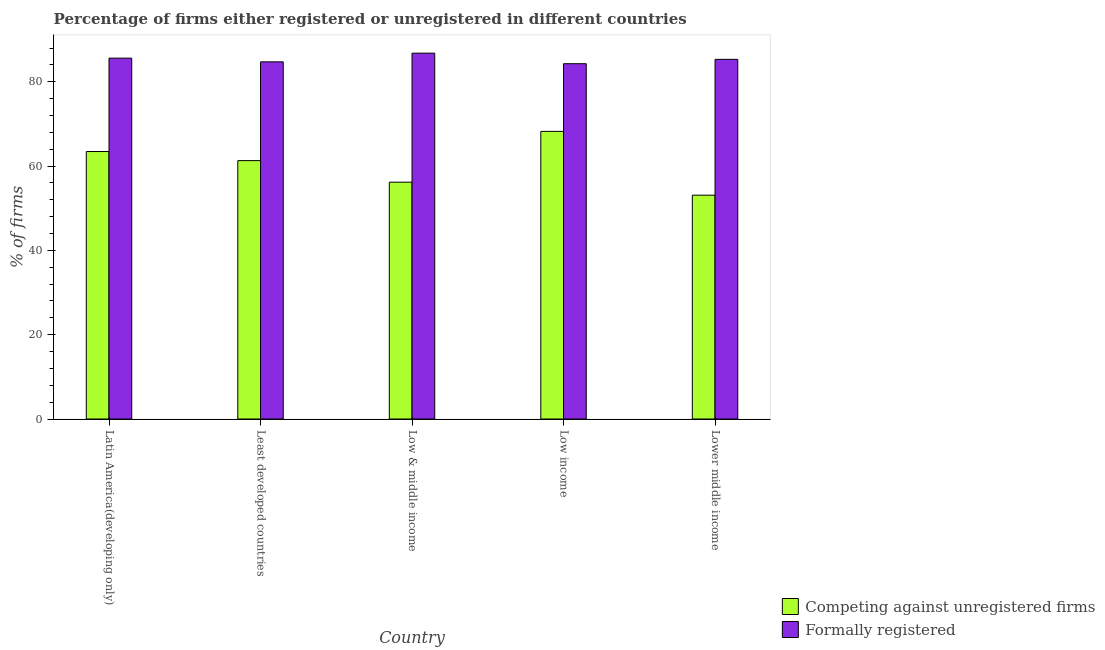Are the number of bars per tick equal to the number of legend labels?
Ensure brevity in your answer.  Yes. How many bars are there on the 5th tick from the left?
Keep it short and to the point. 2. What is the label of the 1st group of bars from the left?
Give a very brief answer. Latin America(developing only). In how many cases, is the number of bars for a given country not equal to the number of legend labels?
Your response must be concise. 0. What is the percentage of registered firms in Low income?
Offer a terse response. 68.23. Across all countries, what is the maximum percentage of formally registered firms?
Keep it short and to the point. 86.79. Across all countries, what is the minimum percentage of registered firms?
Ensure brevity in your answer.  53.1. In which country was the percentage of formally registered firms minimum?
Offer a very short reply. Low income. What is the total percentage of formally registered firms in the graph?
Keep it short and to the point. 426.72. What is the difference between the percentage of formally registered firms in Least developed countries and that in Low income?
Give a very brief answer. 0.44. What is the difference between the percentage of formally registered firms in Lower middle income and the percentage of registered firms in Low & middle income?
Make the answer very short. 29.14. What is the average percentage of registered firms per country?
Keep it short and to the point. 60.45. What is the difference between the percentage of registered firms and percentage of formally registered firms in Low income?
Provide a succinct answer. -16.05. In how many countries, is the percentage of registered firms greater than 76 %?
Keep it short and to the point. 0. What is the ratio of the percentage of registered firms in Latin America(developing only) to that in Lower middle income?
Offer a very short reply. 1.2. What is the difference between the highest and the second highest percentage of registered firms?
Your answer should be compact. 4.78. What is the difference between the highest and the lowest percentage of registered firms?
Your answer should be compact. 15.13. In how many countries, is the percentage of formally registered firms greater than the average percentage of formally registered firms taken over all countries?
Offer a terse response. 2. What does the 1st bar from the left in Latin America(developing only) represents?
Offer a very short reply. Competing against unregistered firms. What does the 2nd bar from the right in Low income represents?
Your answer should be very brief. Competing against unregistered firms. How many bars are there?
Offer a very short reply. 10. How many countries are there in the graph?
Provide a succinct answer. 5. Does the graph contain any zero values?
Your answer should be very brief. No. Does the graph contain grids?
Keep it short and to the point. No. Where does the legend appear in the graph?
Keep it short and to the point. Bottom right. What is the title of the graph?
Your answer should be compact. Percentage of firms either registered or unregistered in different countries. Does "Canada" appear as one of the legend labels in the graph?
Provide a short and direct response. No. What is the label or title of the X-axis?
Offer a very short reply. Country. What is the label or title of the Y-axis?
Keep it short and to the point. % of firms. What is the % of firms of Competing against unregistered firms in Latin America(developing only)?
Keep it short and to the point. 63.45. What is the % of firms of Formally registered in Latin America(developing only)?
Your answer should be compact. 85.6. What is the % of firms in Competing against unregistered firms in Least developed countries?
Your response must be concise. 61.3. What is the % of firms in Formally registered in Least developed countries?
Provide a short and direct response. 84.72. What is the % of firms in Competing against unregistered firms in Low & middle income?
Offer a very short reply. 56.18. What is the % of firms of Formally registered in Low & middle income?
Your answer should be compact. 86.79. What is the % of firms in Competing against unregistered firms in Low income?
Keep it short and to the point. 68.23. What is the % of firms in Formally registered in Low income?
Your response must be concise. 84.28. What is the % of firms of Competing against unregistered firms in Lower middle income?
Give a very brief answer. 53.1. What is the % of firms in Formally registered in Lower middle income?
Offer a terse response. 85.32. Across all countries, what is the maximum % of firms of Competing against unregistered firms?
Ensure brevity in your answer.  68.23. Across all countries, what is the maximum % of firms of Formally registered?
Provide a succinct answer. 86.79. Across all countries, what is the minimum % of firms of Competing against unregistered firms?
Ensure brevity in your answer.  53.1. Across all countries, what is the minimum % of firms of Formally registered?
Give a very brief answer. 84.28. What is the total % of firms of Competing against unregistered firms in the graph?
Keep it short and to the point. 302.26. What is the total % of firms in Formally registered in the graph?
Keep it short and to the point. 426.72. What is the difference between the % of firms in Competing against unregistered firms in Latin America(developing only) and that in Least developed countries?
Your answer should be very brief. 2.16. What is the difference between the % of firms of Formally registered in Latin America(developing only) and that in Least developed countries?
Provide a succinct answer. 0.88. What is the difference between the % of firms in Competing against unregistered firms in Latin America(developing only) and that in Low & middle income?
Provide a short and direct response. 7.28. What is the difference between the % of firms of Formally registered in Latin America(developing only) and that in Low & middle income?
Your answer should be very brief. -1.18. What is the difference between the % of firms of Competing against unregistered firms in Latin America(developing only) and that in Low income?
Provide a succinct answer. -4.78. What is the difference between the % of firms of Formally registered in Latin America(developing only) and that in Low income?
Offer a very short reply. 1.32. What is the difference between the % of firms of Competing against unregistered firms in Latin America(developing only) and that in Lower middle income?
Keep it short and to the point. 10.36. What is the difference between the % of firms of Formally registered in Latin America(developing only) and that in Lower middle income?
Your response must be concise. 0.28. What is the difference between the % of firms of Competing against unregistered firms in Least developed countries and that in Low & middle income?
Provide a short and direct response. 5.12. What is the difference between the % of firms in Formally registered in Least developed countries and that in Low & middle income?
Your answer should be compact. -2.06. What is the difference between the % of firms in Competing against unregistered firms in Least developed countries and that in Low income?
Offer a terse response. -6.93. What is the difference between the % of firms of Formally registered in Least developed countries and that in Low income?
Your answer should be compact. 0.44. What is the difference between the % of firms of Competing against unregistered firms in Least developed countries and that in Lower middle income?
Offer a very short reply. 8.2. What is the difference between the % of firms in Formally registered in Least developed countries and that in Lower middle income?
Your answer should be very brief. -0.59. What is the difference between the % of firms in Competing against unregistered firms in Low & middle income and that in Low income?
Offer a terse response. -12.05. What is the difference between the % of firms in Formally registered in Low & middle income and that in Low income?
Your answer should be compact. 2.5. What is the difference between the % of firms of Competing against unregistered firms in Low & middle income and that in Lower middle income?
Provide a short and direct response. 3.08. What is the difference between the % of firms in Formally registered in Low & middle income and that in Lower middle income?
Offer a terse response. 1.47. What is the difference between the % of firms of Competing against unregistered firms in Low income and that in Lower middle income?
Provide a short and direct response. 15.13. What is the difference between the % of firms in Formally registered in Low income and that in Lower middle income?
Provide a succinct answer. -1.04. What is the difference between the % of firms of Competing against unregistered firms in Latin America(developing only) and the % of firms of Formally registered in Least developed countries?
Provide a short and direct response. -21.27. What is the difference between the % of firms of Competing against unregistered firms in Latin America(developing only) and the % of firms of Formally registered in Low & middle income?
Provide a succinct answer. -23.33. What is the difference between the % of firms of Competing against unregistered firms in Latin America(developing only) and the % of firms of Formally registered in Low income?
Offer a terse response. -20.83. What is the difference between the % of firms in Competing against unregistered firms in Latin America(developing only) and the % of firms in Formally registered in Lower middle income?
Offer a terse response. -21.87. What is the difference between the % of firms in Competing against unregistered firms in Least developed countries and the % of firms in Formally registered in Low & middle income?
Keep it short and to the point. -25.49. What is the difference between the % of firms of Competing against unregistered firms in Least developed countries and the % of firms of Formally registered in Low income?
Ensure brevity in your answer.  -22.99. What is the difference between the % of firms of Competing against unregistered firms in Least developed countries and the % of firms of Formally registered in Lower middle income?
Your answer should be very brief. -24.02. What is the difference between the % of firms in Competing against unregistered firms in Low & middle income and the % of firms in Formally registered in Low income?
Keep it short and to the point. -28.1. What is the difference between the % of firms of Competing against unregistered firms in Low & middle income and the % of firms of Formally registered in Lower middle income?
Offer a very short reply. -29.14. What is the difference between the % of firms of Competing against unregistered firms in Low income and the % of firms of Formally registered in Lower middle income?
Your response must be concise. -17.09. What is the average % of firms of Competing against unregistered firms per country?
Provide a succinct answer. 60.45. What is the average % of firms in Formally registered per country?
Give a very brief answer. 85.34. What is the difference between the % of firms of Competing against unregistered firms and % of firms of Formally registered in Latin America(developing only)?
Your response must be concise. -22.15. What is the difference between the % of firms in Competing against unregistered firms and % of firms in Formally registered in Least developed countries?
Give a very brief answer. -23.43. What is the difference between the % of firms of Competing against unregistered firms and % of firms of Formally registered in Low & middle income?
Your response must be concise. -30.61. What is the difference between the % of firms in Competing against unregistered firms and % of firms in Formally registered in Low income?
Offer a very short reply. -16.05. What is the difference between the % of firms in Competing against unregistered firms and % of firms in Formally registered in Lower middle income?
Your answer should be very brief. -32.22. What is the ratio of the % of firms in Competing against unregistered firms in Latin America(developing only) to that in Least developed countries?
Offer a terse response. 1.04. What is the ratio of the % of firms in Formally registered in Latin America(developing only) to that in Least developed countries?
Offer a terse response. 1.01. What is the ratio of the % of firms of Competing against unregistered firms in Latin America(developing only) to that in Low & middle income?
Provide a short and direct response. 1.13. What is the ratio of the % of firms in Formally registered in Latin America(developing only) to that in Low & middle income?
Offer a very short reply. 0.99. What is the ratio of the % of firms of Competing against unregistered firms in Latin America(developing only) to that in Low income?
Give a very brief answer. 0.93. What is the ratio of the % of firms in Formally registered in Latin America(developing only) to that in Low income?
Provide a succinct answer. 1.02. What is the ratio of the % of firms of Competing against unregistered firms in Latin America(developing only) to that in Lower middle income?
Your answer should be compact. 1.2. What is the ratio of the % of firms of Formally registered in Latin America(developing only) to that in Lower middle income?
Your answer should be very brief. 1. What is the ratio of the % of firms of Competing against unregistered firms in Least developed countries to that in Low & middle income?
Give a very brief answer. 1.09. What is the ratio of the % of firms in Formally registered in Least developed countries to that in Low & middle income?
Provide a short and direct response. 0.98. What is the ratio of the % of firms in Competing against unregistered firms in Least developed countries to that in Low income?
Offer a very short reply. 0.9. What is the ratio of the % of firms in Formally registered in Least developed countries to that in Low income?
Keep it short and to the point. 1.01. What is the ratio of the % of firms in Competing against unregistered firms in Least developed countries to that in Lower middle income?
Keep it short and to the point. 1.15. What is the ratio of the % of firms of Formally registered in Least developed countries to that in Lower middle income?
Keep it short and to the point. 0.99. What is the ratio of the % of firms of Competing against unregistered firms in Low & middle income to that in Low income?
Make the answer very short. 0.82. What is the ratio of the % of firms in Formally registered in Low & middle income to that in Low income?
Ensure brevity in your answer.  1.03. What is the ratio of the % of firms of Competing against unregistered firms in Low & middle income to that in Lower middle income?
Offer a very short reply. 1.06. What is the ratio of the % of firms of Formally registered in Low & middle income to that in Lower middle income?
Keep it short and to the point. 1.02. What is the ratio of the % of firms of Competing against unregistered firms in Low income to that in Lower middle income?
Provide a short and direct response. 1.28. What is the difference between the highest and the second highest % of firms in Competing against unregistered firms?
Make the answer very short. 4.78. What is the difference between the highest and the second highest % of firms in Formally registered?
Offer a terse response. 1.18. What is the difference between the highest and the lowest % of firms in Competing against unregistered firms?
Your answer should be compact. 15.13. What is the difference between the highest and the lowest % of firms of Formally registered?
Your response must be concise. 2.5. 